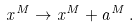Convert formula to latex. <formula><loc_0><loc_0><loc_500><loc_500>x ^ { M } \rightarrow x ^ { M } + a ^ { M } \, .</formula> 